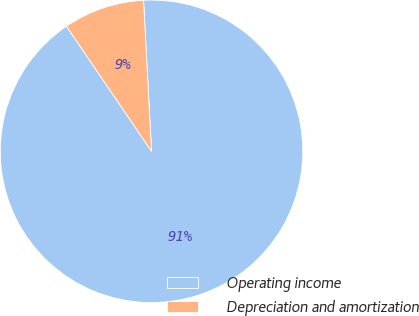<chart> <loc_0><loc_0><loc_500><loc_500><pie_chart><fcel>Operating income<fcel>Depreciation and amortization<nl><fcel>91.33%<fcel>8.67%<nl></chart> 